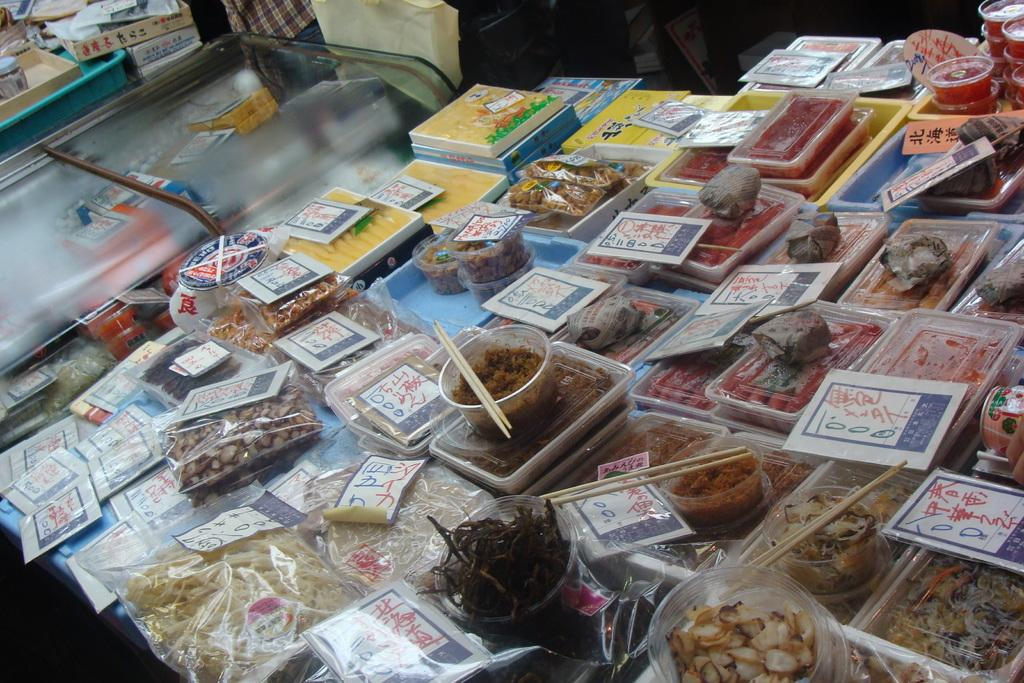What type of containers can be seen in the image? There are boxes in the image. What utensils are present in the image? There are chopsticks in the image. What type of food-related items can be seen in the image? There are food packets and food items in the image. Where are the objects located in the image? The objects are on a table. What is the unique container in the image? There is a glass box in the image. What type of question is being asked by the tramp in the image? There is no tramp present in the image, and therefore no question being asked. 